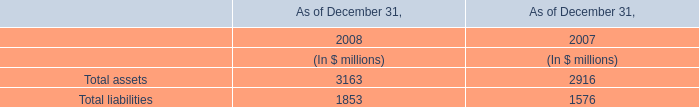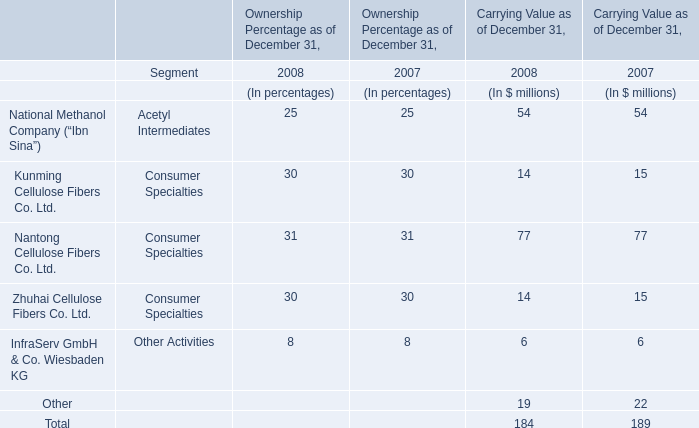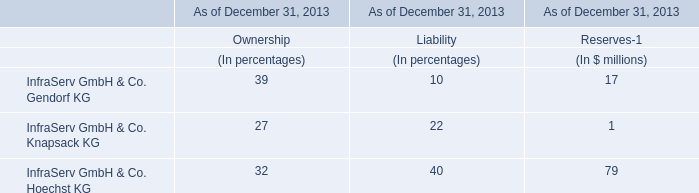How many years does Nantong Cellulose Fibers Co. Ltd. stay higher than Zhuhai Cellulose Fibers Co. Ltd. for Carrying Value as of December 31? 
Answer: 2. 